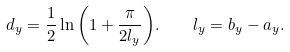Convert formula to latex. <formula><loc_0><loc_0><loc_500><loc_500>d _ { y } = \frac { 1 } { 2 } \ln { \left ( 1 + \frac { \pi } { 2 l _ { y } } \right ) } . \quad l _ { y } = b _ { y } - a _ { y } .</formula> 